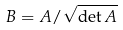Convert formula to latex. <formula><loc_0><loc_0><loc_500><loc_500>B = A / \sqrt { \det A }</formula> 